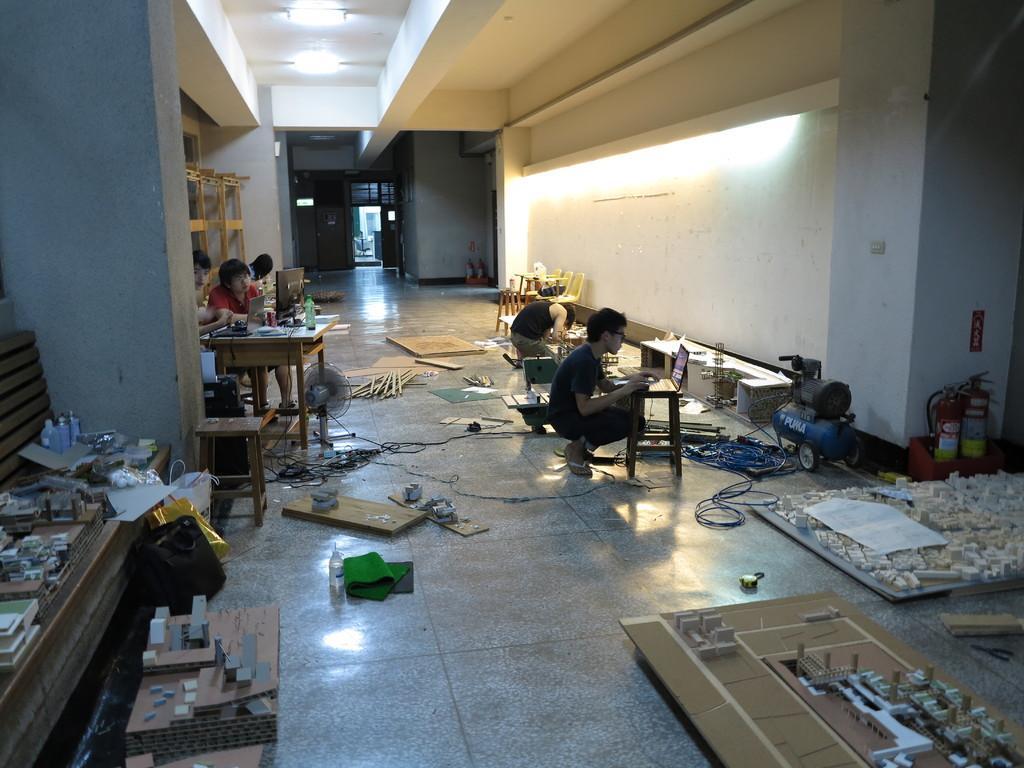Can you describe this image briefly? In this image we can see some people sitting and we can also see wooden objects, walls, lights and roof. 